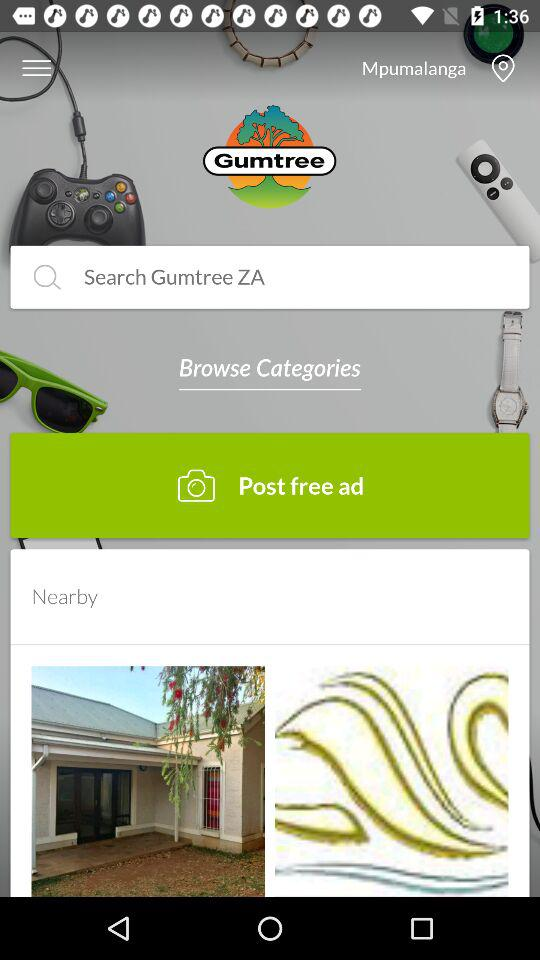When was the free ad posted?
When the provided information is insufficient, respond with <no answer>. <no answer> 